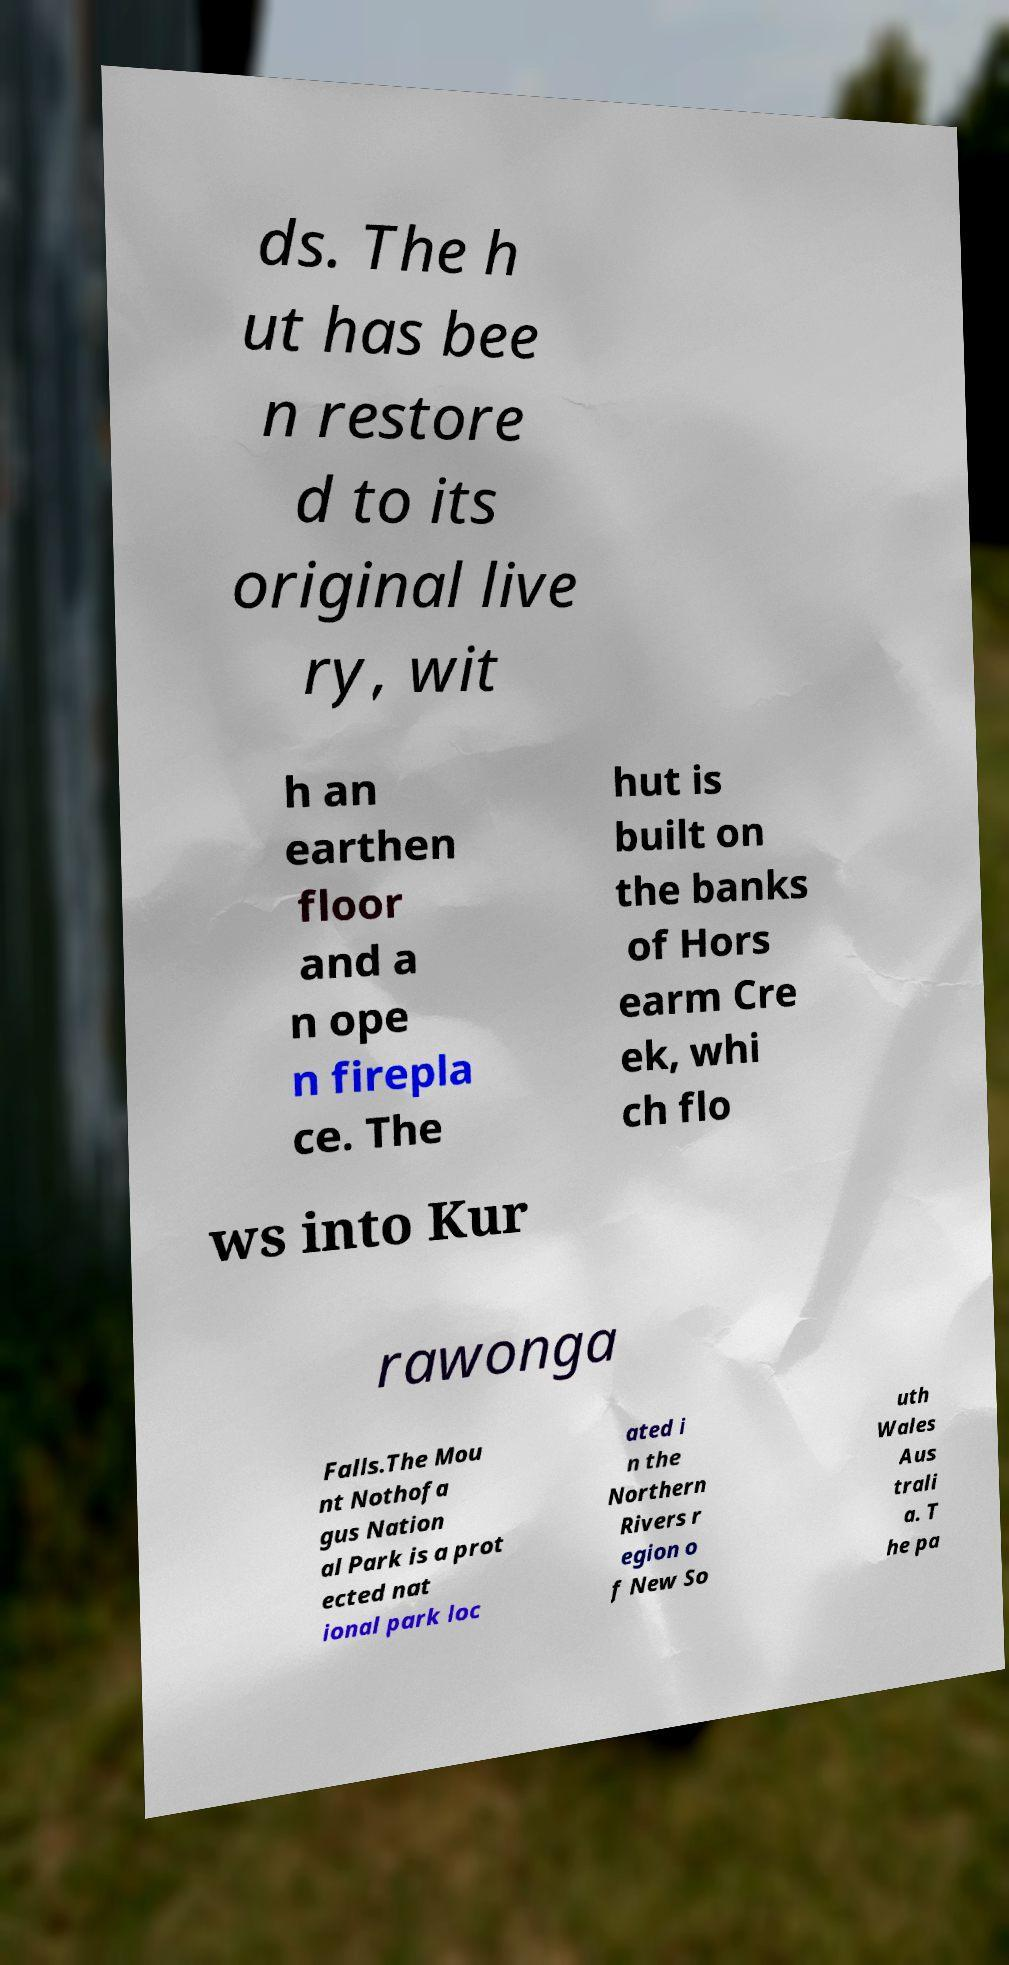Please identify and transcribe the text found in this image. ds. The h ut has bee n restore d to its original live ry, wit h an earthen floor and a n ope n firepla ce. The hut is built on the banks of Hors earm Cre ek, whi ch flo ws into Kur rawonga Falls.The Mou nt Nothofa gus Nation al Park is a prot ected nat ional park loc ated i n the Northern Rivers r egion o f New So uth Wales Aus trali a. T he pa 